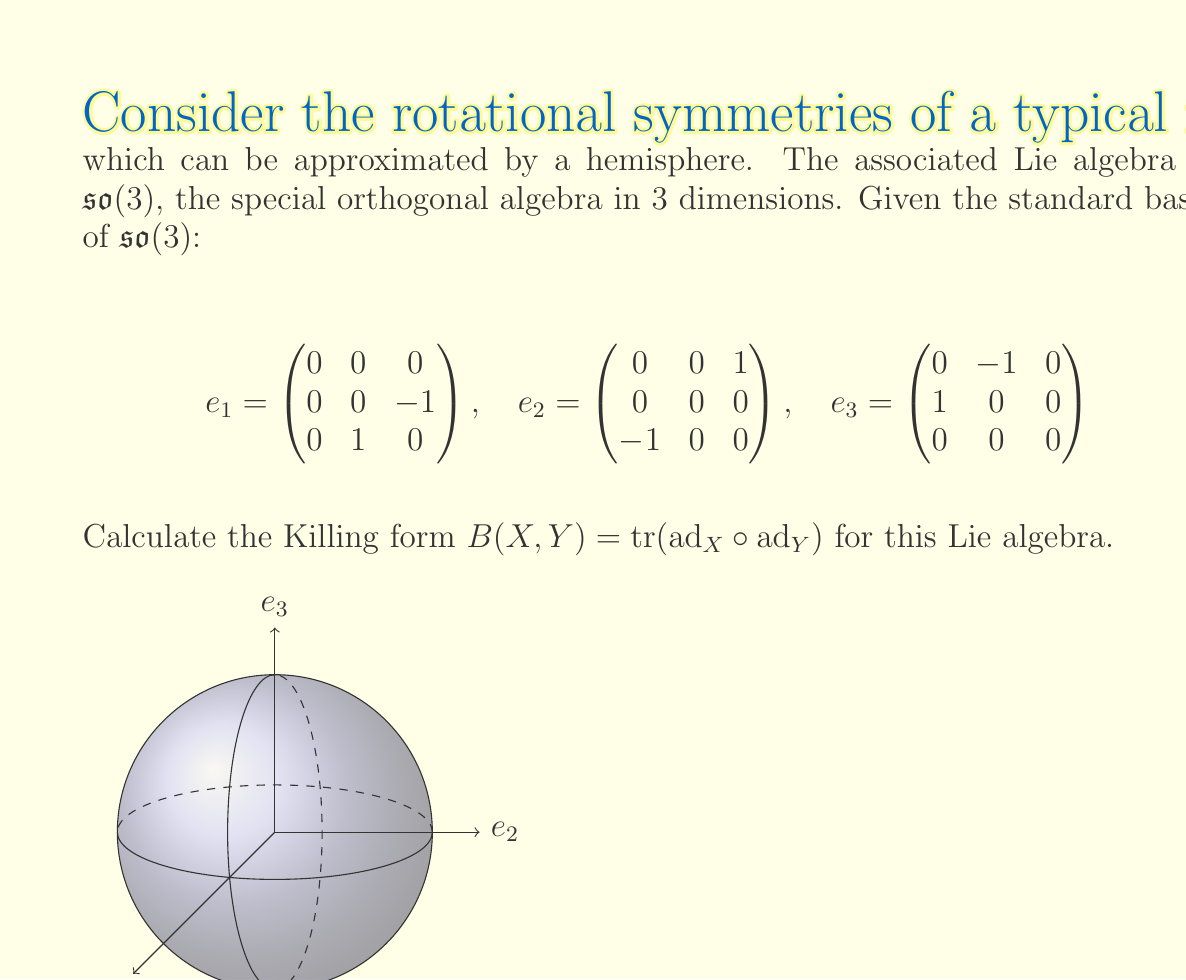Can you solve this math problem? To calculate the Killing form, we need to follow these steps:

1) First, we need to compute the adjoint representations $\text{ad}_{e_i}$ for each basis element. The adjoint representation is defined by $\text{ad}_X(Y) = [X,Y]$.

2) For $\mathfrak{so}(3)$, we have the following commutation relations:
   $[e_1,e_2] = e_3$, $[e_2,e_3] = e_1$, $[e_3,e_1] = e_2$

3) Using these, we can compute the matrices of $\text{ad}_{e_i}$:

   $\text{ad}_{e_1} = \begin{pmatrix}
   0 & 0 & 0 \\
   0 & 0 & -1 \\
   0 & 1 & 0
   \end{pmatrix}$

   $\text{ad}_{e_2} = \begin{pmatrix}
   0 & 0 & 1 \\
   0 & 0 & 0 \\
   -1 & 0 & 0
   \end{pmatrix}$

   $\text{ad}_{e_3} = \begin{pmatrix}
   0 & -1 & 0 \\
   1 & 0 & 0 \\
   0 & 0 & 0
   \end{pmatrix}$

4) Now, we need to compute $B(e_i,e_j) = \text{tr}(\text{ad}_{e_i} \circ \text{ad}_{e_j})$ for all $i,j \in \{1,2,3\}$:

   $B(e_1,e_1) = \text{tr}(\text{ad}_{e_1}^2) = -2$
   $B(e_2,e_2) = \text{tr}(\text{ad}_{e_2}^2) = -2$
   $B(e_3,e_3) = \text{tr}(\text{ad}_{e_3}^2) = -2$
   $B(e_1,e_2) = B(e_2,e_1) = \text{tr}(\text{ad}_{e_1} \circ \text{ad}_{e_2}) = 0$
   $B(e_1,e_3) = B(e_3,e_1) = \text{tr}(\text{ad}_{e_1} \circ \text{ad}_{e_3}) = 0$
   $B(e_2,e_3) = B(e_3,e_2) = \text{tr}(\text{ad}_{e_2} \circ \text{ad}_{e_3}) = 0$

5) Therefore, the Killing form can be represented as the matrix:

   $B = \begin{pmatrix}
   -2 & 0 & 0 \\
   0 & -2 & 0 \\
   0 & 0 & -2
   \end{pmatrix}$

This Killing form is negative definite, which is a characteristic of compact Lie algebras like $\mathfrak{so}(3)$.
Answer: $B = -2I_3$, where $I_3$ is the $3\times3$ identity matrix. 